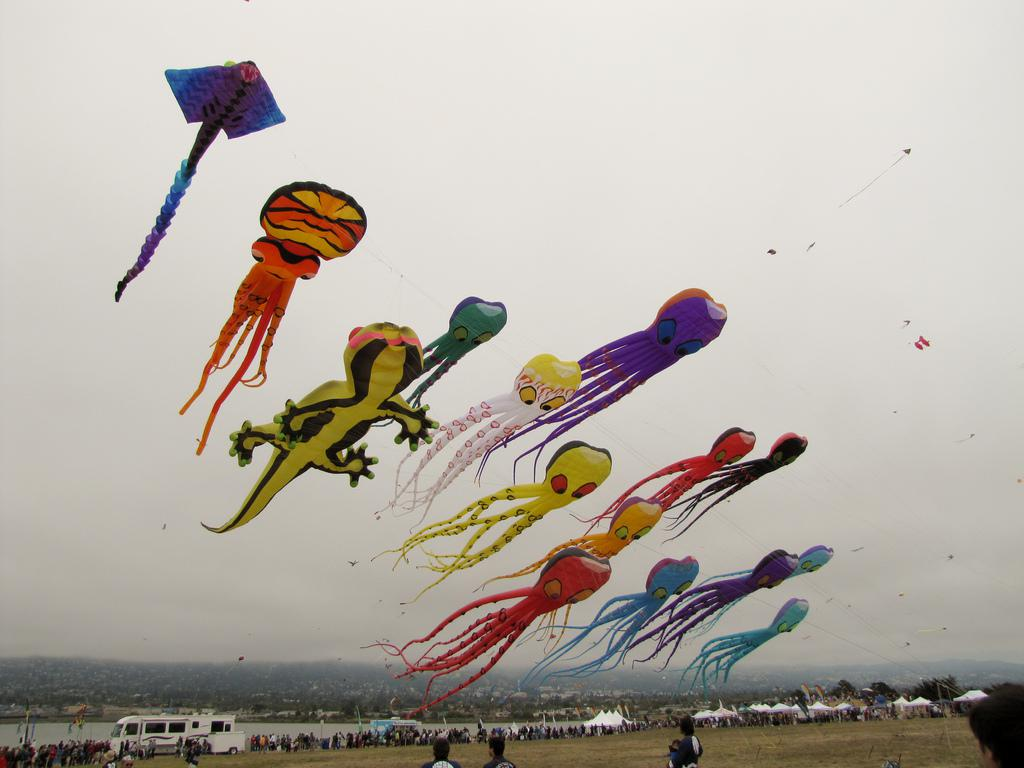Question: what are the things in the sky?
Choices:
A. Kites.
B. Clouds.
C. Planes.
D. Birds.
Answer with the letter. Answer: A Question: what do the kites look like?
Choices:
A. Dragons.
B. Snakes.
C. Alligator.
D. Sea creatures.
Answer with the letter. Answer: D Question: what keeps the kites from drifting away?
Choices:
A. There is no wind.
B. It's raining.
C. The kite is broke.
D. The people holding the strings.
Answer with the letter. Answer: D Question: why are they so high?
Choices:
A. The wind.
B. The breeze is keeping them aloft.
C. It's stormy.
D. Breezes.
Answer with the letter. Answer: B Question: who is at the other end of the kites?
Choices:
A. A key.
B. The dogs tied to the strings.
C. No one. The kites blew away.
D. The people holding the strings.
Answer with the letter. Answer: D Question: what is parked nearby?
Choices:
A. Motorcycle.
B. Truck.
C. A motorhome.
D. Police car.
Answer with the letter. Answer: C Question: what are the kites?
Choices:
A. Very colorful.
B. Plain.
C. Dark.
D. Solid colored.
Answer with the letter. Answer: A Question: what do the kites have?
Choices:
A. Bows.
B. String.
C. Short tails.
D. Long tails.
Answer with the letter. Answer: D Question: where are the tents?
Choices:
A. In the clearing.
B. Nearby.
C. Near  the riverbank.
D. At the store.
Answer with the letter. Answer: B Question: how does the kites appear?
Choices:
A. A dragon.
B. An owl.
C. A butterfly.
D. Squid.
Answer with the letter. Answer: D Question: what is in the distance?
Choices:
A. Mountains.
B. Hills.
C. A river.
D. A forest.
Answer with the letter. Answer: B Question: where are the kites?
Choices:
A. In the sky.
B. In flight.
C. In the car trunk.
D. At the toy store.
Answer with the letter. Answer: B Question: where is a lake?
Choices:
A. In town.
B. In background.
C. In the backyard.
D. On the side of the road.
Answer with the letter. Answer: B Question: what kind of day is it?
Choices:
A. Cold.
B. Warm.
C. Dreary.
D. Windy.
Answer with the letter. Answer: C Question: what does it appear to be doing in the distance?
Choices:
A. Snowing.
B. Fogging up.
C. Hailing.
D. Raining.
Answer with the letter. Answer: D Question: what is in a distance?
Choices:
A. A truck.
B. A trailer.
C. A car.
D. A bus.
Answer with the letter. Answer: B Question: what scene is this?
Choices:
A. Inside scene.
B. Winter scene.
C. Summer scene.
D. Outside scene.
Answer with the letter. Answer: D 